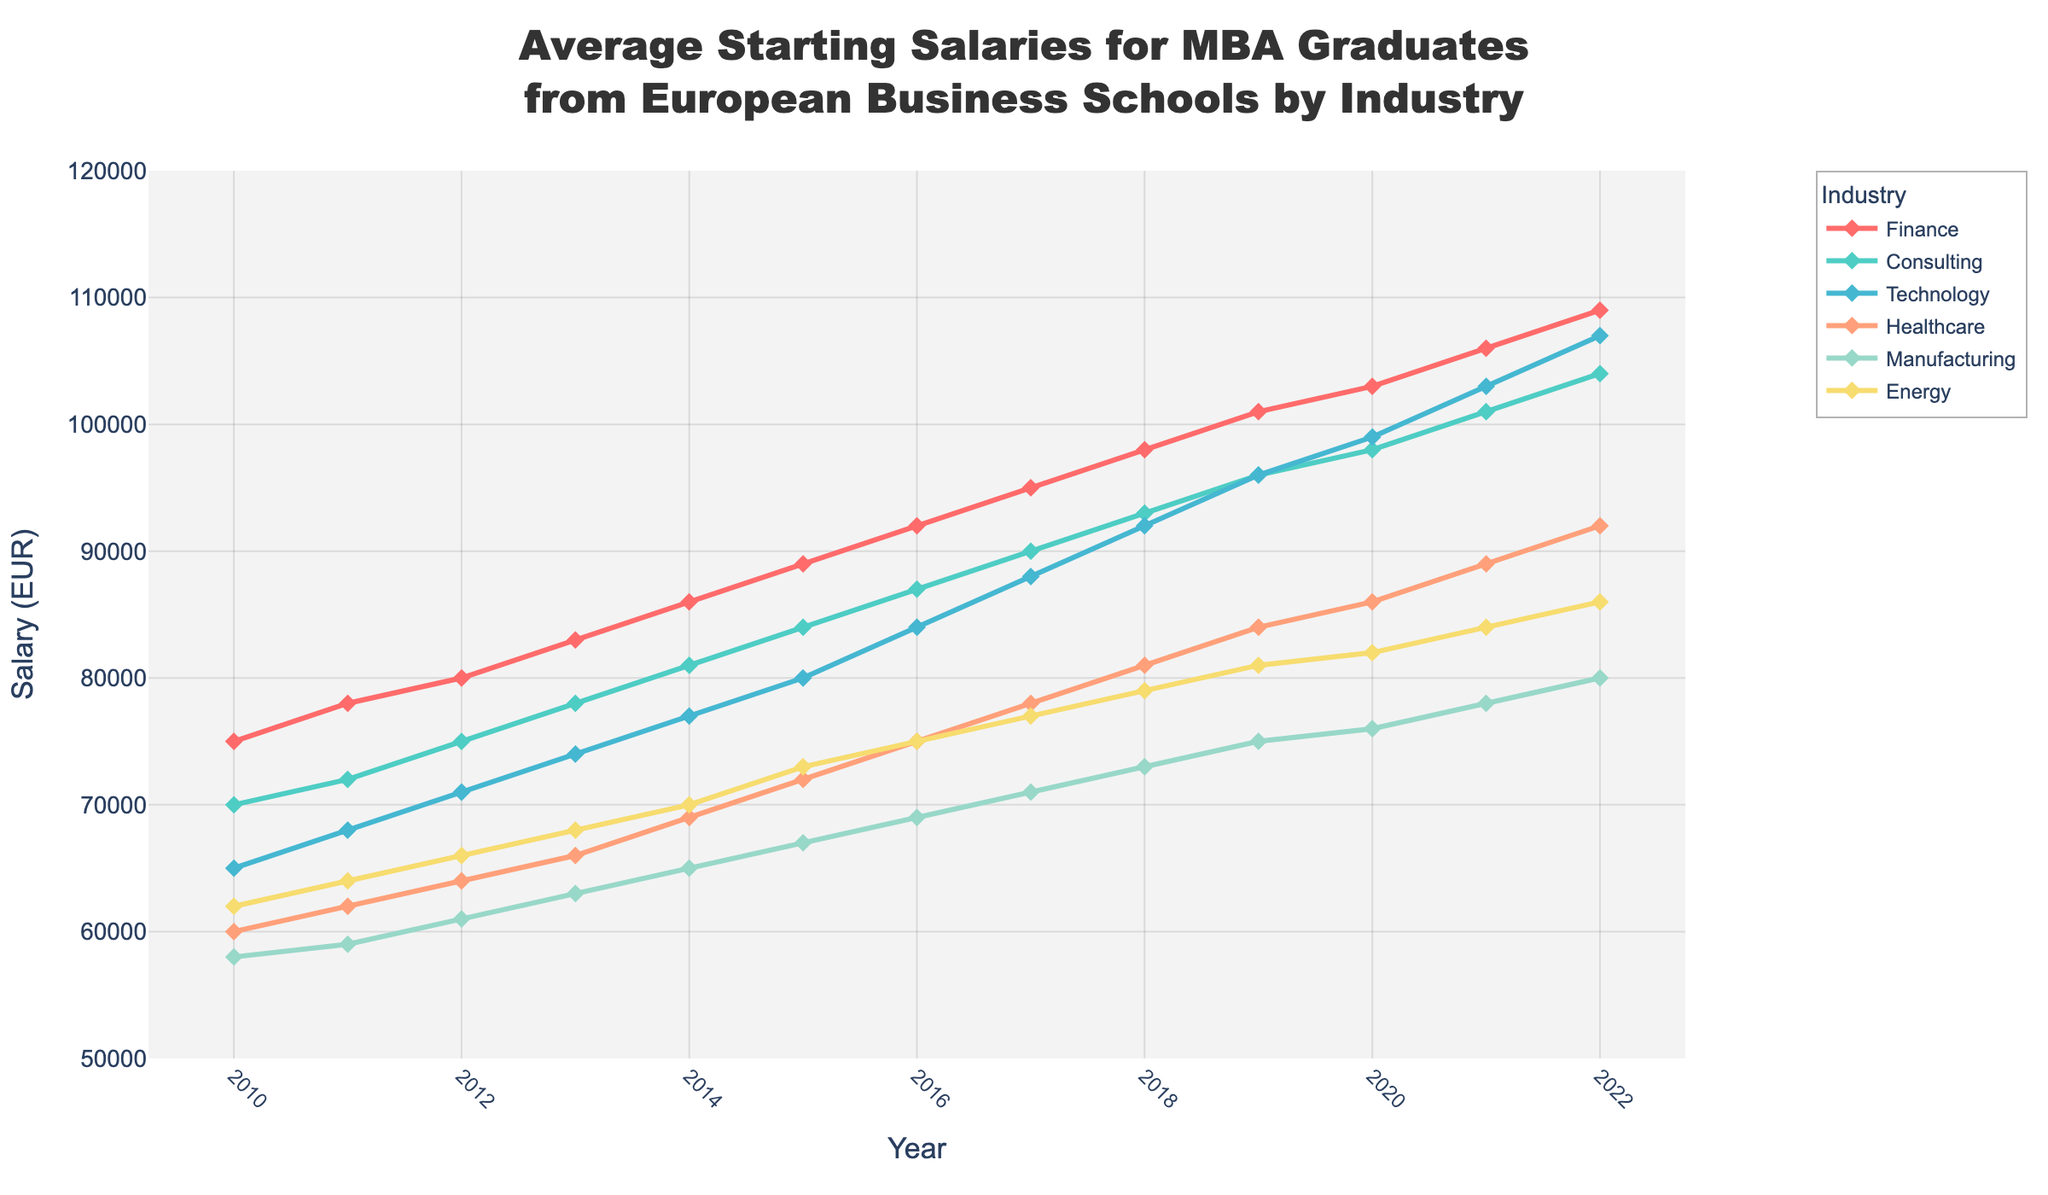what is the difference between the starting salary in Finance and Healthcare in 2022? The starting salary in Finance in 2022 is €109,000, and in Healthcare it is €92,000. The difference is calculated as €109,000 - €92,000 = €17,000
Answer: €17,000 which industry saw the highest increase in average starting salary from 2010 to 2022? To find the highest increase, we subtract the 2010 salary from the 2022 salary for each industry. Finance: €109,000 - €75,000 = €34,000, Consulting: €104,000 - €70,000 = €34,000, Technology: €107,000 - €65,000 = €42,000, Healthcare: €92,000 - €60,000 = €32,000, Manufacturing: €80,000 - €58,000 = €22,000, Energy: €86,000 - €62,000 = €24,000. Technology has the highest increase
Answer: Technology how does the starting salary trend for Consulting compare with Technology between 2010 and 2022? The trend lines for Consulting and Technology show a similar upward trajectory from 2010 to 2022. Both industries show a consistent increase in starting salaries over the years, but Technology's salaries increased slightly more sharply, especially starting from around 2015
Answer: Both increased, but Technology increased more sharply in which year did Consulting salaries surpass €90,000? By examining the trend line for Consulting, we see that it surpassed €90,000 in the year 2017
Answer: 2017 what was the average starting salary for Energy between 2010 and 2022? To find the average, sum all the starting salaries in Energy from 2010 to 2022 and divide by the number of years: (62,000 + 64,000 + 66,000 + 68,000 + 70,000 + 73,000 + 75,000 + 77,000 + 79,000 + 81,000 + 82,000 + 84,000 + 86,000) / 13 years = €74,769
Answer: €74,769 what is the ratio of Technology to Manufacturing salaries in 2020? In 2020, the starting salary for Technology is €99,000 and for Manufacturing it is €76,000. The ratio is 99,000 / 76,000 ≈ 1.30
Answer: 1.30 which was higher in 2015: the average starting salary for Manufacturing or Healthcare? In 2015, the starting salary for Manufacturing is €67,000 and for Healthcare it is €72,000
Answer: Healthcare how much did the starting salary for Finance increase from 2016 to 2018? In 2016, the starting salary for Finance is €92,000 and in 2018 it is €98,000. The increase is €98,000 - €92,000 = €6,000
Answer: €6,000 which year saw the smallest difference in starting salaries between Energy and Manufacturing? By examining the trend lines, we notice that in 2016, the salaries for Energy (€75,000) and Manufacturing (€69,000) were the closest. The difference is €75,000 - €69,000 = €6,000
Answer: 2016 